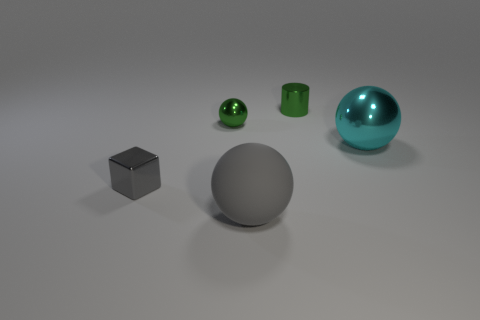Subtract all big spheres. How many spheres are left? 1 Add 4 large metallic balls. How many objects exist? 9 Subtract all green balls. How many balls are left? 2 Subtract 1 spheres. How many spheres are left? 2 Subtract all small purple rubber cylinders. Subtract all cylinders. How many objects are left? 4 Add 4 green metallic cylinders. How many green metallic cylinders are left? 5 Add 2 big red metallic cylinders. How many big red metallic cylinders exist? 2 Subtract 1 cyan balls. How many objects are left? 4 Subtract all cylinders. How many objects are left? 4 Subtract all green blocks. Subtract all gray cylinders. How many blocks are left? 1 